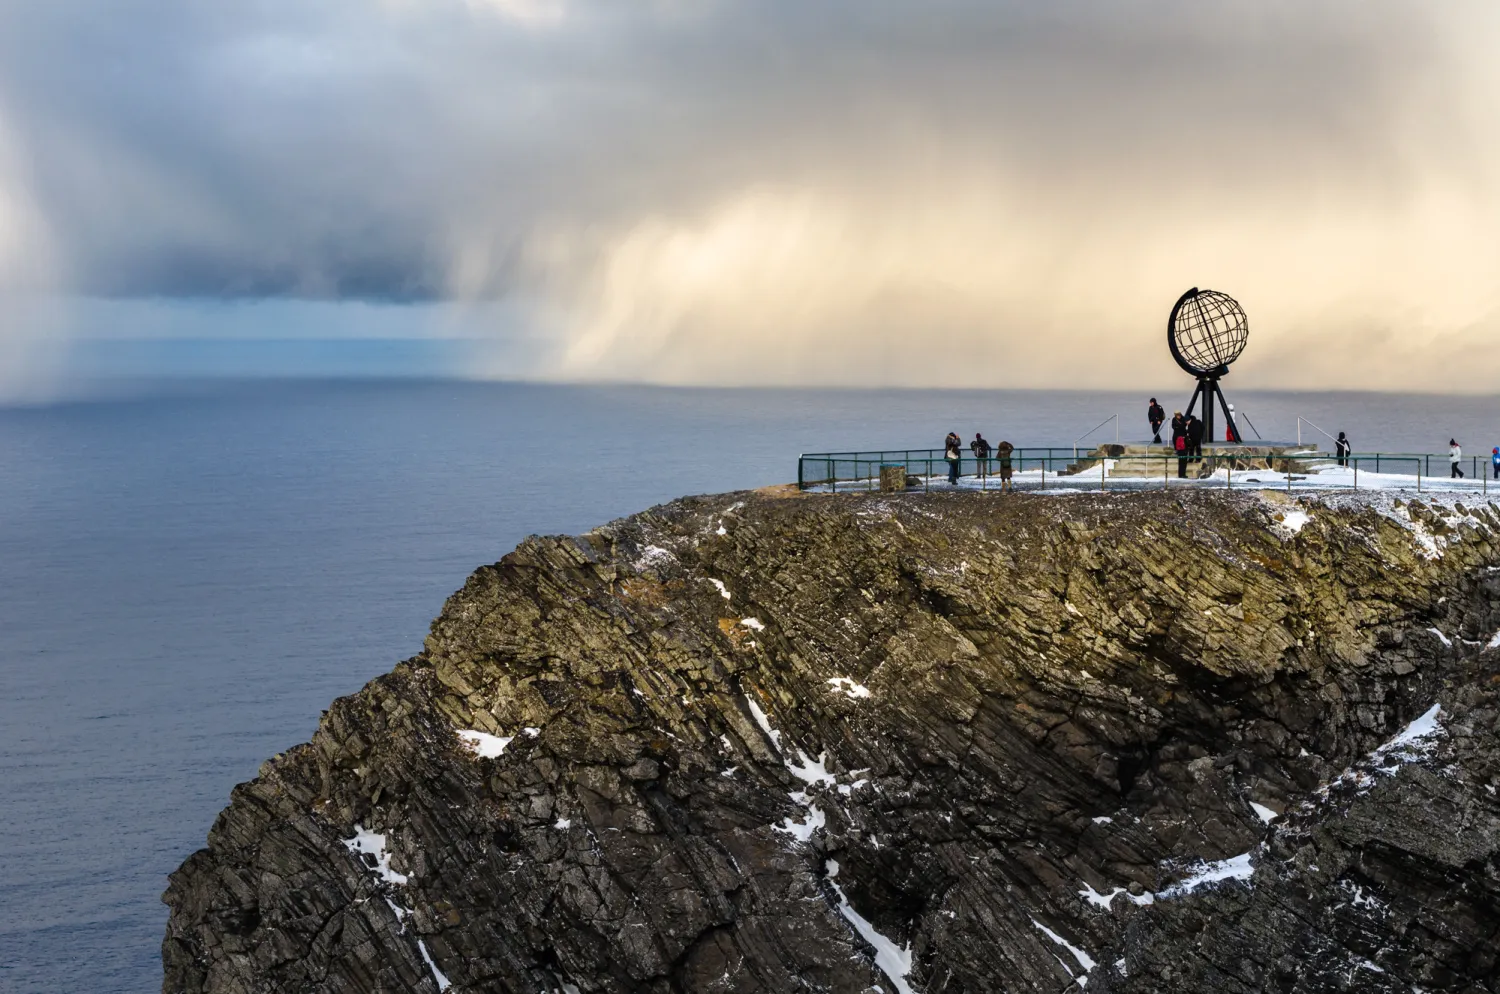Analyze the image in a comprehensive and detailed manner. The image captures the dramatic and remote beauty of North Cape, Norway's northernmost point accessible to tourists. The photograph shows a steep cliff face, characterized by rocky textures and patchy snow, suggesting harsh climatic conditions. Dominating the scene is a symbolic metal globe sculpture, marking this significant geographic location. Around the globe, a few visitors can be seen, dwarfed by the grandeur of the landscape, which emphasizes the vastness and isolation of the area. The ocean extends to the horizon, meeting a sky streaked with light filtering through dense clouds, creating a serene yet austere atmosphere. This location is not only a natural wonder but also a cultural landmark, drawing visitors who wish to experience the edge of the world. 